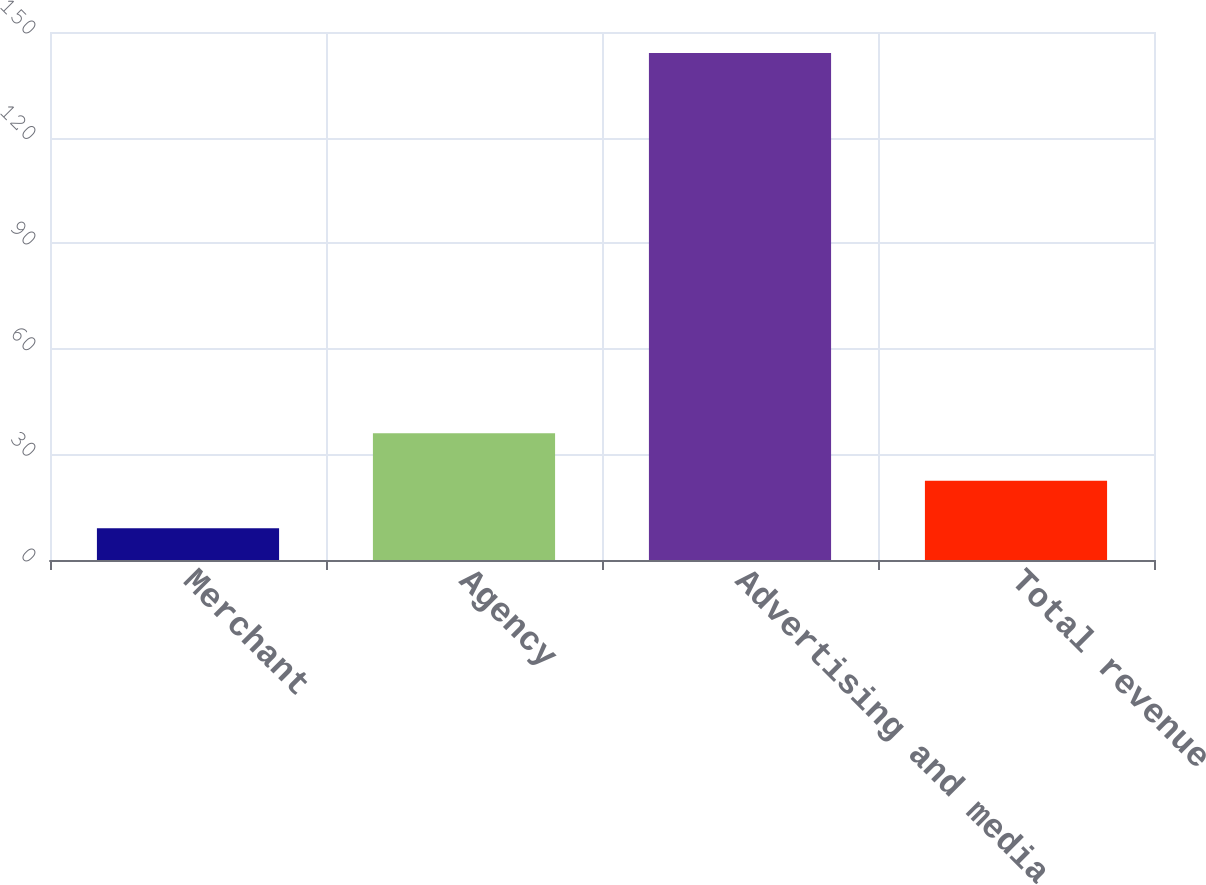Convert chart to OTSL. <chart><loc_0><loc_0><loc_500><loc_500><bar_chart><fcel>Merchant<fcel>Agency<fcel>Advertising and media<fcel>Total revenue<nl><fcel>9<fcel>36<fcel>144<fcel>22.5<nl></chart> 